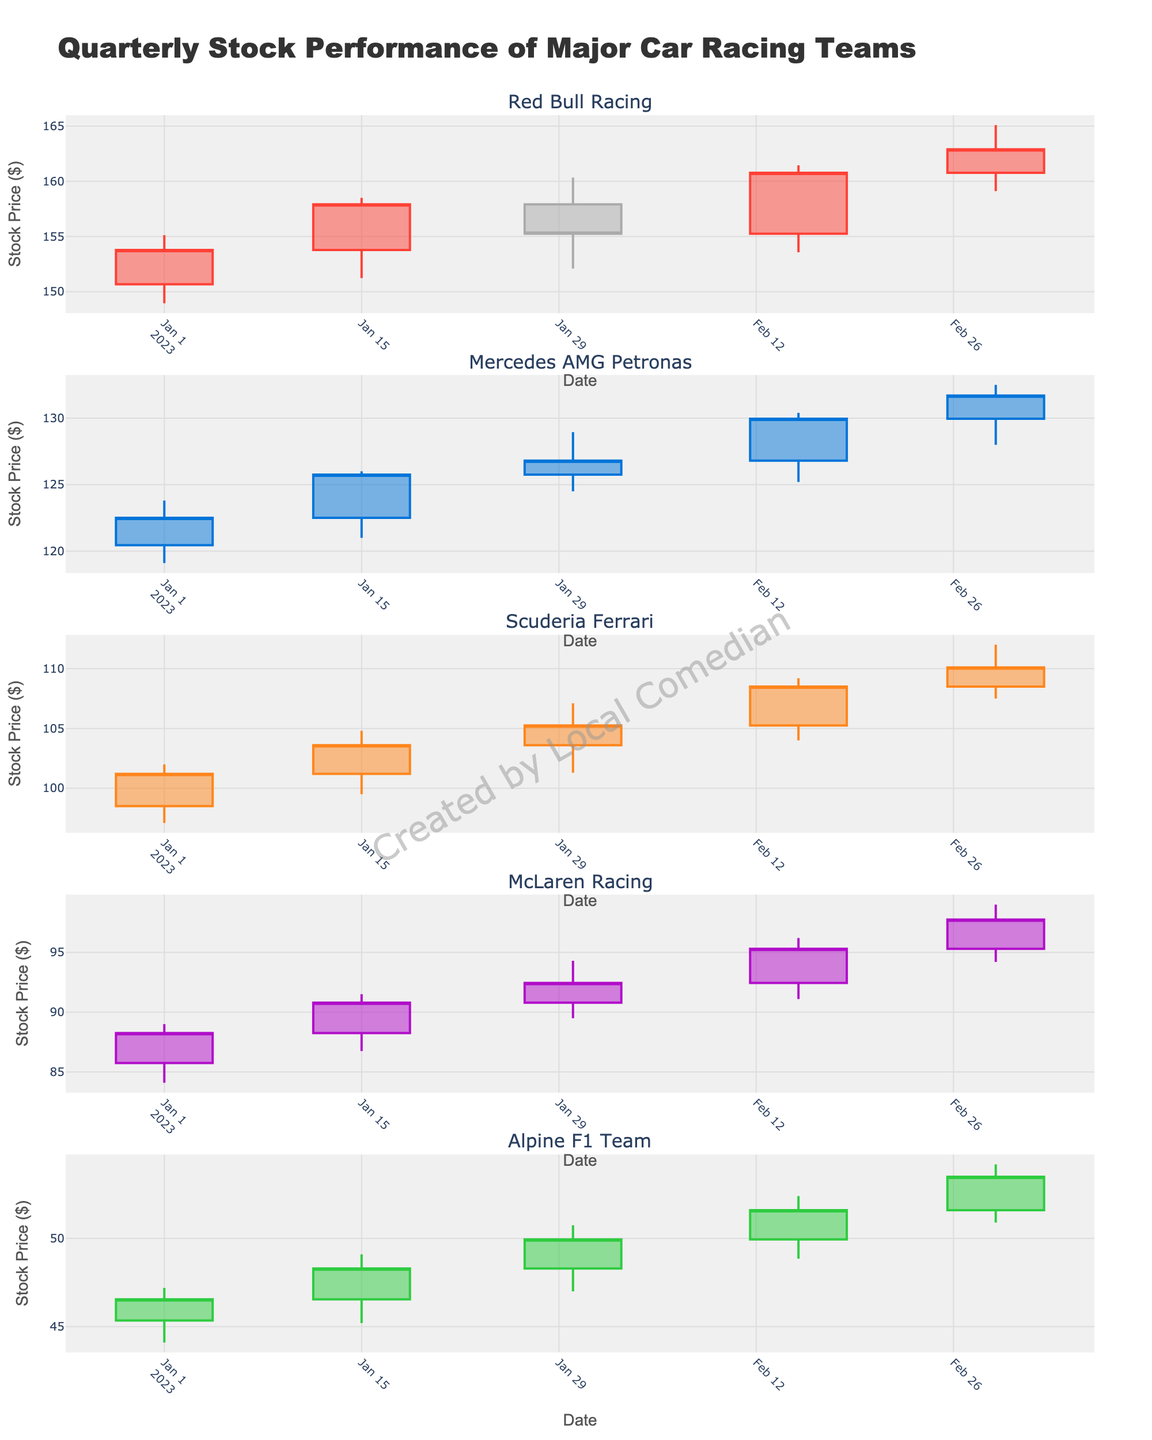How many teams are displayed in the figure? The figure shows the stock performance of multiple car racing teams. Each subplot is for a different team. Count the distinct subplot titles.
Answer: 5 What colors are used to indicate increasing stock prices for each team? Observing from the candlestick color scheme, different colors are used to show increasing prices for each team. Identify the line colors for each team's increasing prices.
Answer: Red, Blue, Orange, Purple, Green Which team had the highest closing stock price on March 1, 2023? Examine the closing price on March 1, 2023, for each team and compare them to determine which is the highest.
Answer: Red Bull Racing What's the difference between the highest and lowest stock price recorded for Scuderia Ferrari? Find the highest high and the lowest low on Scuderia Ferrari's subplot. Subtract the lowest value from the highest value.
Answer: 14.9 On which date did McLaren Racing have the largest range (high minus low) in stock prices? For each date, calculate the range (high - low) for McLaren Racing by examining their subplot. Identify the date with the largest range.
Answer: February 15, 2023 Which team showed the most consistent upward trend in closing prices over the quarter? By observing the pattern of closing prices over time for all teams, identify which team's closing prices consistently increased.
Answer: Alpine F1 Team How does the closing stock price of Alpine F1 Team on March 1, 2023, compare to its opening price on January 1, 2023? Compare the opening price for Alpine F1 Team on January 1, 2023, to its closing price on March 1, 2023.
Answer: Higher What is the overall trend in Mercedes AMG Petronas' stock prices over the quarter? Observe the pattern of the candlesticks for Mercedes AMG Petronas. Determine the general direction of the closing prices from January to March.
Answer: Upward Which team's stock prices showed the greatest volatility within the quarter? Volatility can be perceived by the range between high and low prices in the candlestick plots. Identify which team's candlestick ranges vary the most.
Answer: Red Bull Racing What is the closing price of Scuderia Ferrari on February 15, 2023, and how does it compare to the closing price of Red Bull Racing on the same date? Read the closing prices for Scuderia Ferrari and Red Bull Racing on February 15, 2023. Compare the two values to find out which is higher and by how much.
Answer: Scuderia Ferrari: 108.50, Red Bull Racing: 160.78, Difference: 52.28 